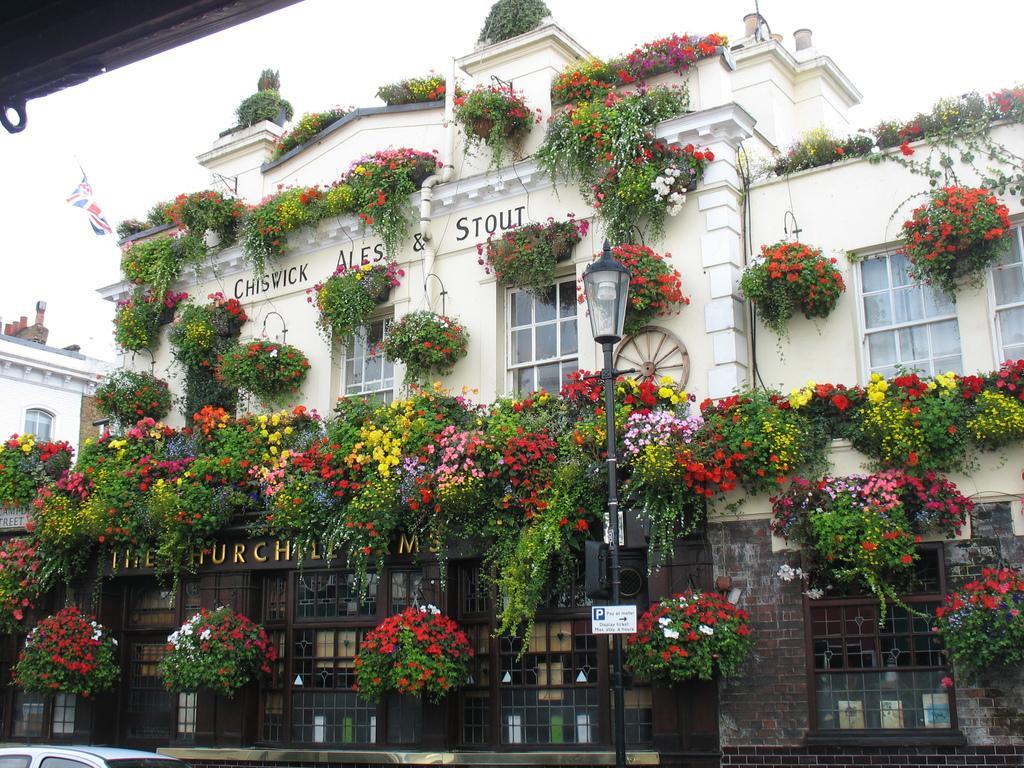How would you summarize this image in a sentence or two? In this picture we can see the buildings. On the building we can see plants, flowers, windows and glass. In front of the building we can see car and street light. At the top we can see sky and clouds. On the left there is a flag on the building. 